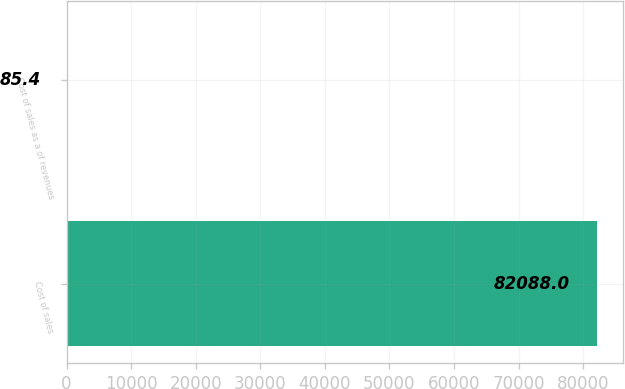Convert chart to OTSL. <chart><loc_0><loc_0><loc_500><loc_500><bar_chart><fcel>Cost of sales<fcel>Cost of sales as a of revenues<nl><fcel>82088<fcel>85.4<nl></chart> 